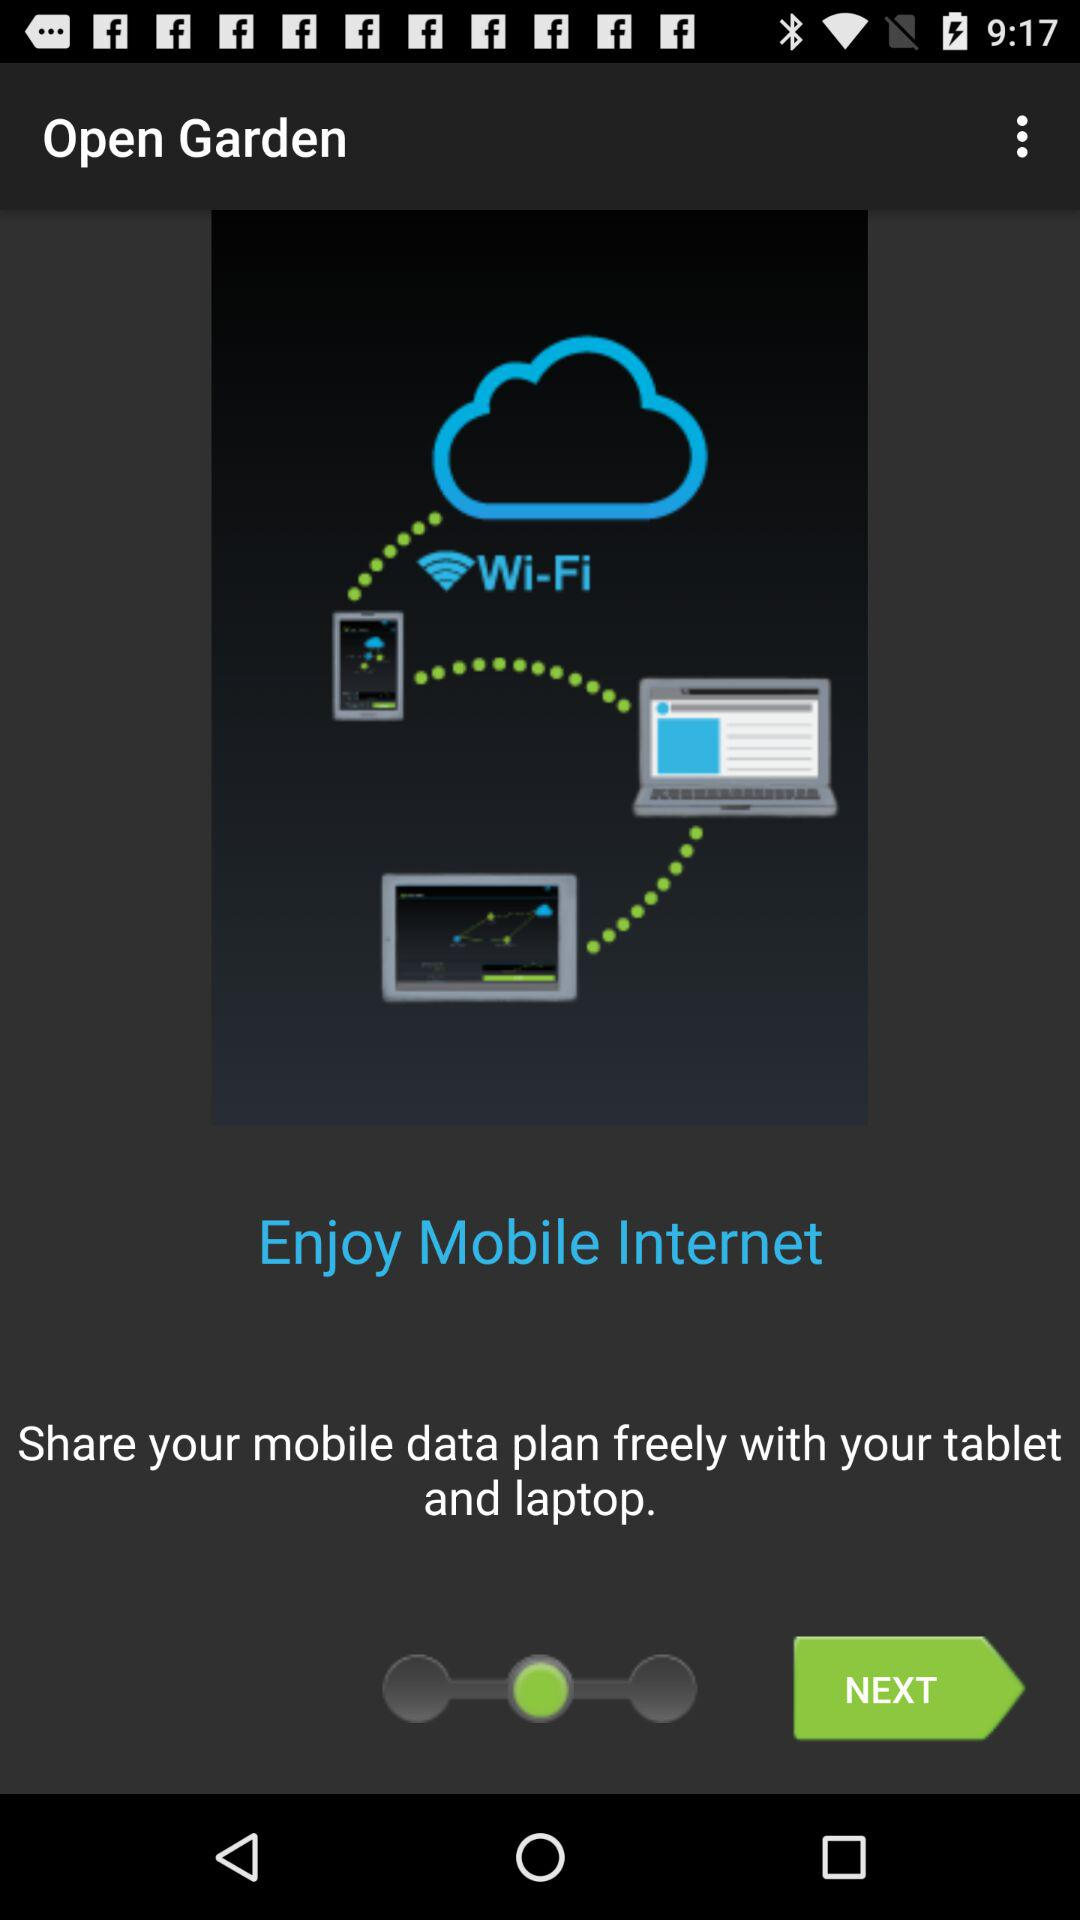How many devices are connected to the cloud?
Answer the question using a single word or phrase. 3 